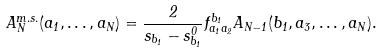Convert formula to latex. <formula><loc_0><loc_0><loc_500><loc_500>A _ { N } ^ { m . s . } ( a _ { 1 } , \dots , a _ { N } ) = \frac { 2 } { s _ { b _ { 1 } } - s _ { b _ { 1 } } ^ { 0 } } f _ { a _ { 1 } a _ { 2 } } ^ { b _ { 1 } } A _ { N - 1 } ( b _ { 1 } , a _ { 3 } , \dots , a _ { N } ) .</formula> 